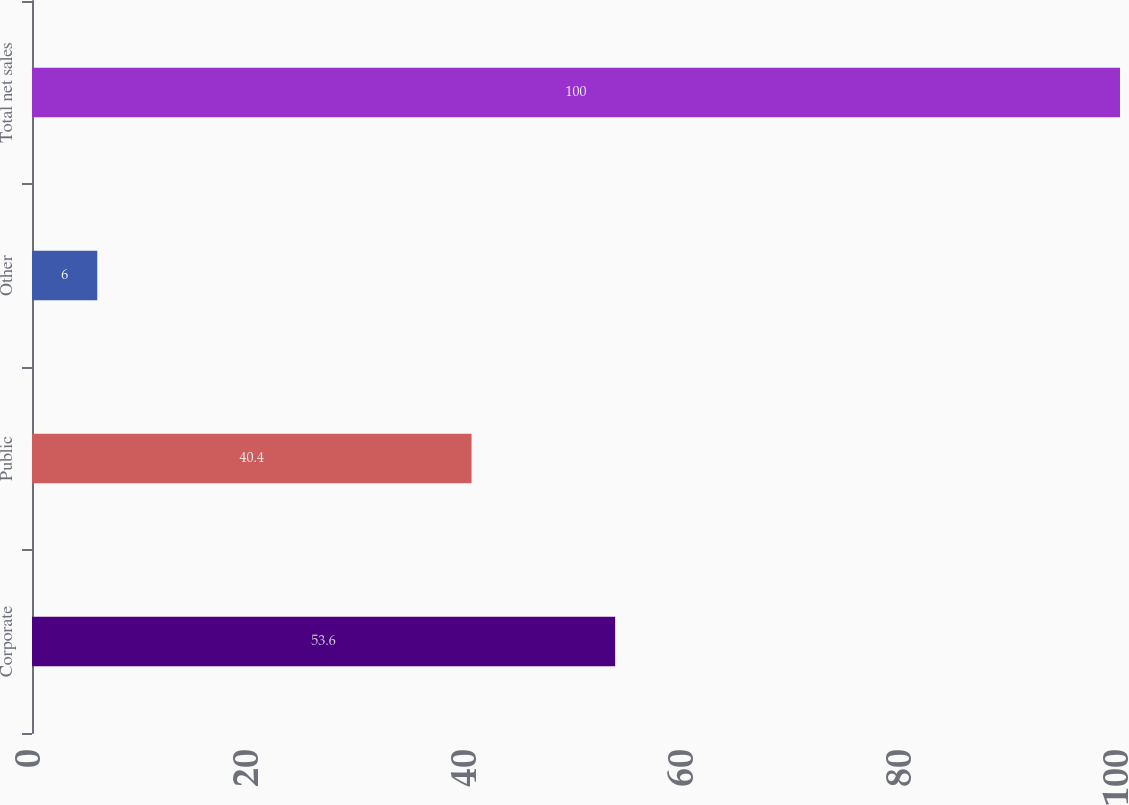<chart> <loc_0><loc_0><loc_500><loc_500><bar_chart><fcel>Corporate<fcel>Public<fcel>Other<fcel>Total net sales<nl><fcel>53.6<fcel>40.4<fcel>6<fcel>100<nl></chart> 